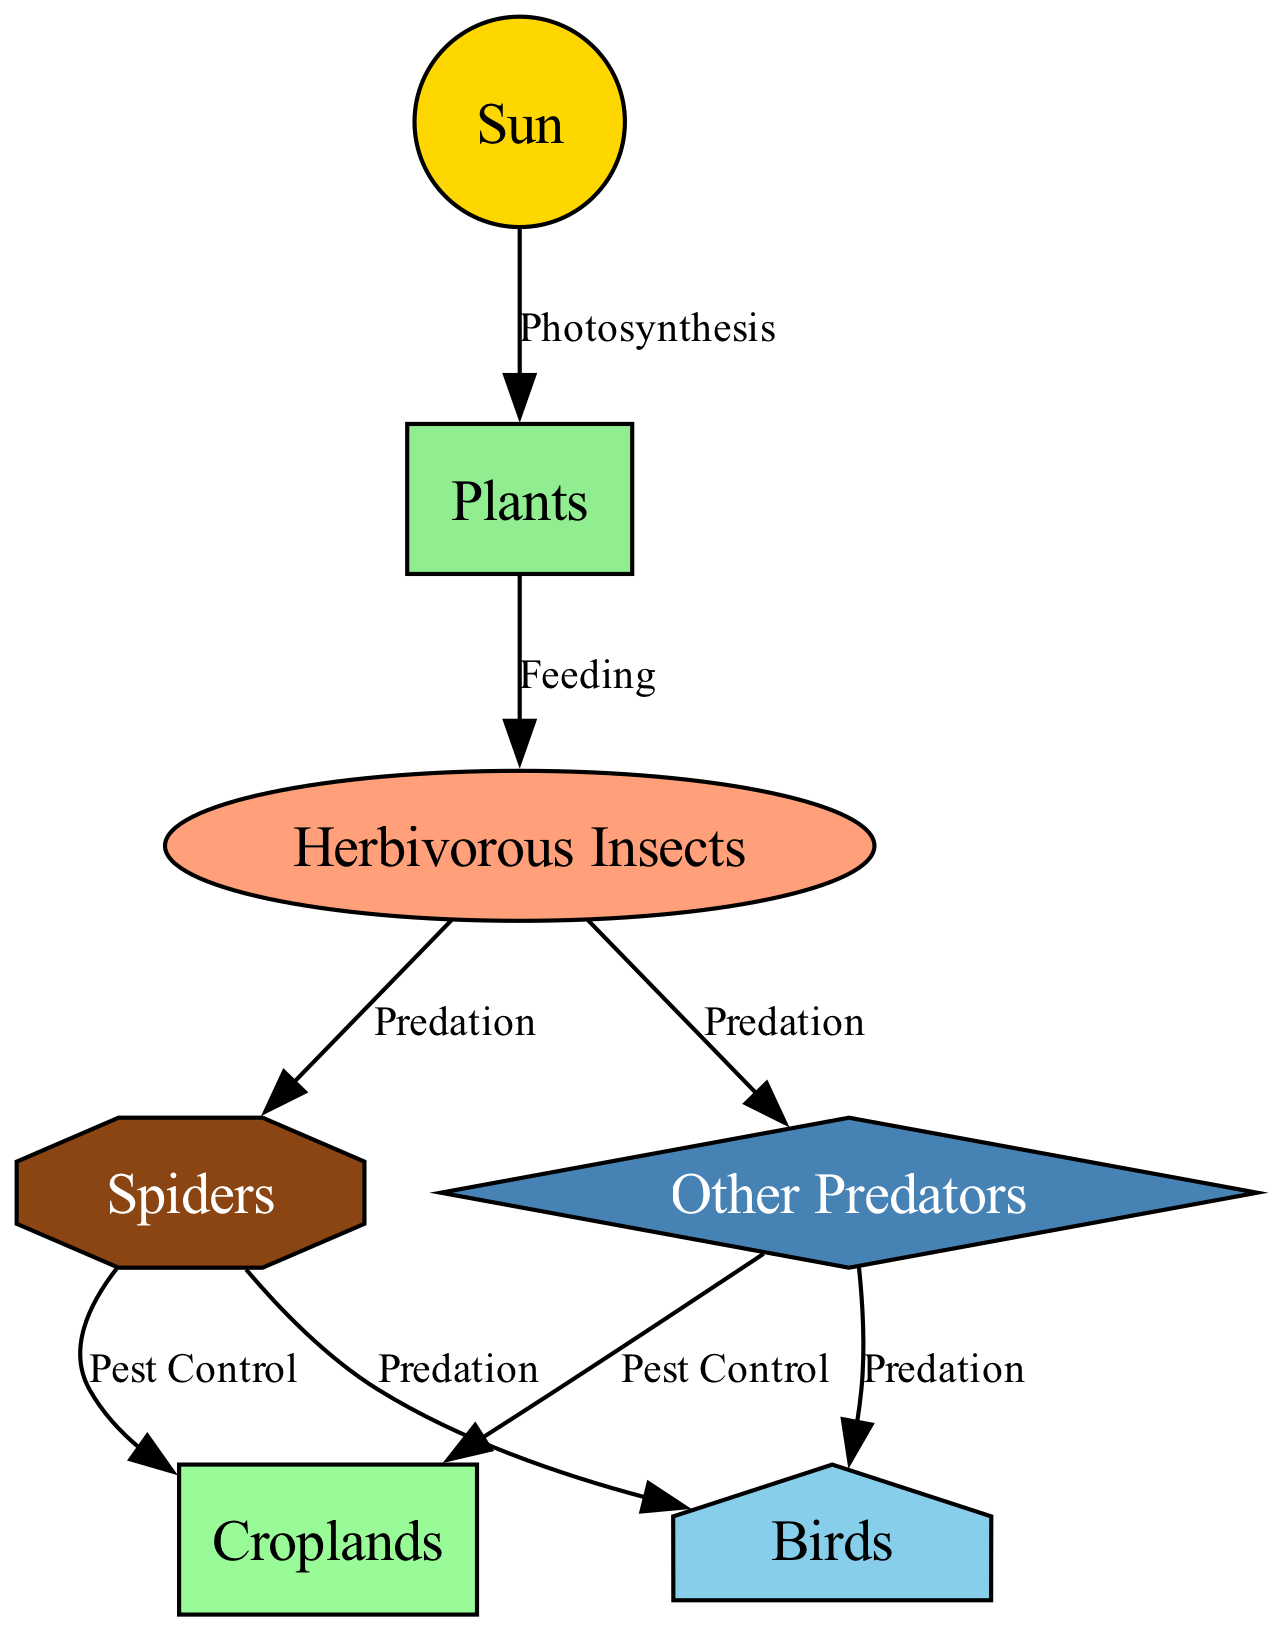What is the primary energy source in the diagram? The diagram indicates the "Sun" as the primary energy source, highlighted as the starting node in the food chain.
Answer: Sun Which node represents producers in the food chain? The "Plants" node is identified as the producers that convert solar energy into biomass, making it the primary producer in the food chain.
Answer: Plants How many predator types are illustrated in the diagram? There are two types of predators shown: "Spiders" and "Other Predators." Both are represented as being involved in insect population control.
Answer: Two What relationship exists between herbivorous insects and spiders? The relationship is labeled "Predation," indicating that herbivorous insects are prey for spiders, reflecting the predator-prey relationship in the food chain.
Answer: Predation Which nodes benefit from spiders due to pest control? The "Croplands" node benefits from spiders, as they help with pest control, leading to improved agricultural yields.
Answer: Croplands How many edges are present in the diagram? The diagram contains a total of seven edges that illustrate the relationships among different nodes in the food chain.
Answer: Seven Which node consumes spiders and other predators? The "Birds" node is specifically illustrated as consuming both spiders and other predators, indicating a higher trophic level in the food chain.
Answer: Birds What type of organisms are referred to as "herbivorous insects"? The "Herbivorous Insects" node represents organisms that consume plants, which are defined as pests in the agricultural context, underscoring their role in the food chain.
Answer: Herbivorous Insects What process connects the sun to plants? The process labeled "Photosynthesis" connects the sun to plants, describing how plants convert solar energy into chemical energy.
Answer: Photosynthesis 